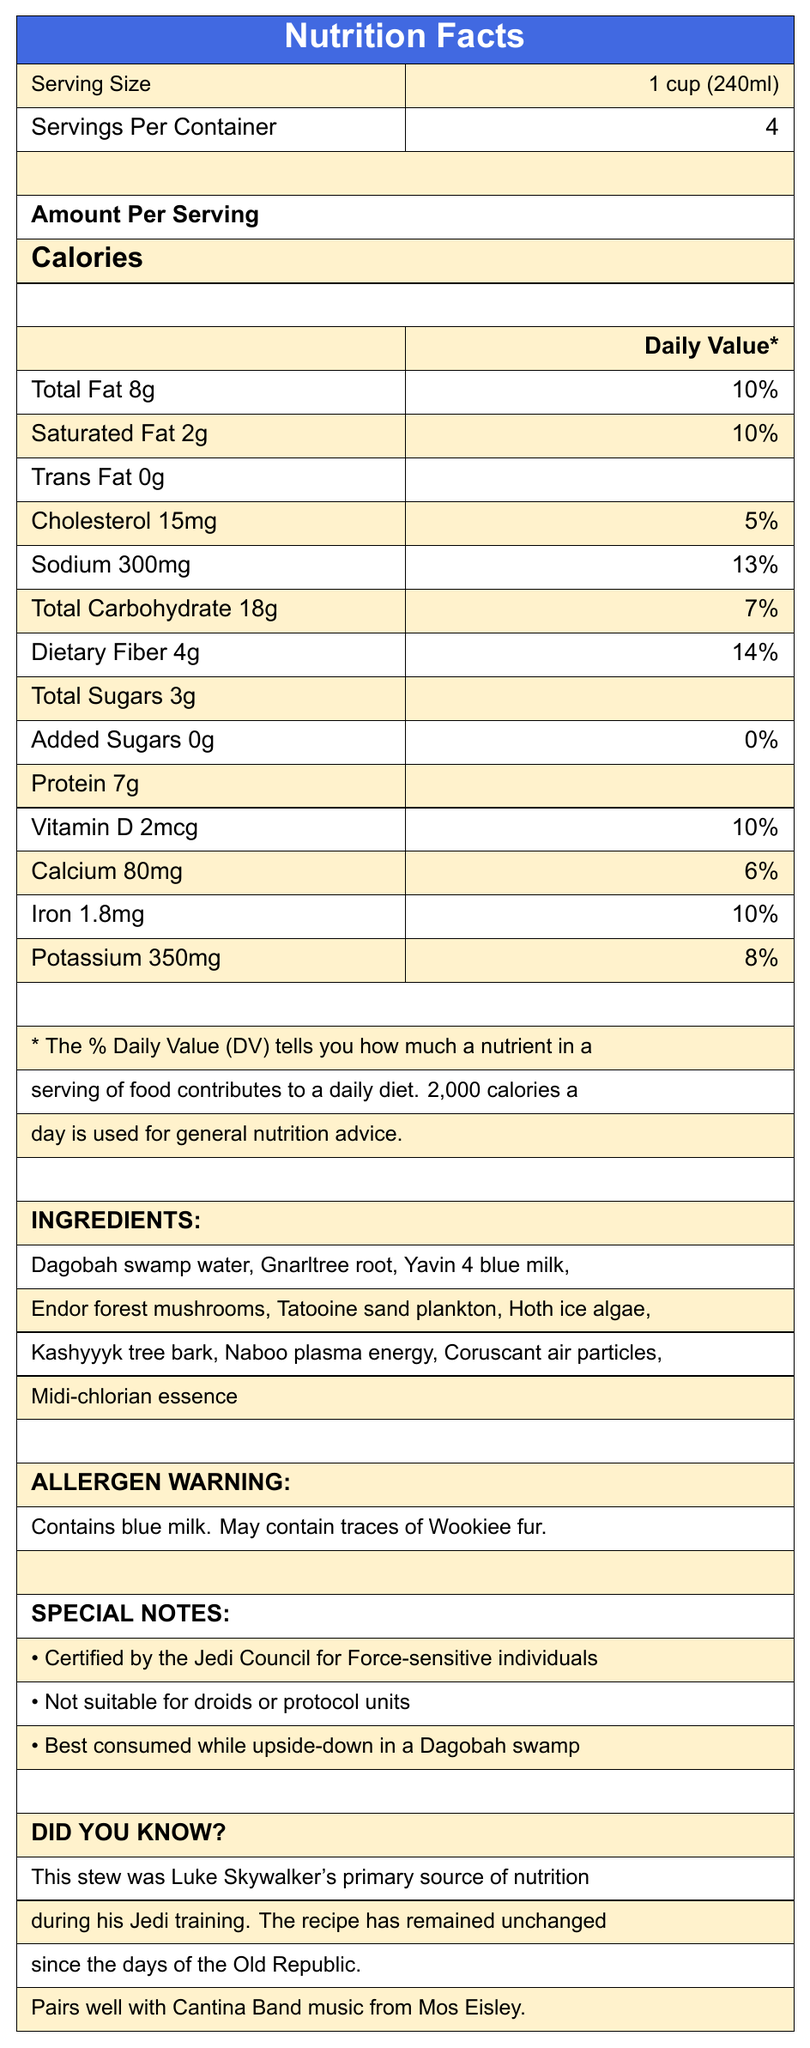what is the serving size? The serving size is explicitly mentioned as 1 cup (240ml) under the "Serving Size" section of the document.
Answer: 1 cup (240ml) how many calories are in one serving? The document states that there are 150 calories per serving under the "Calories" section.
Answer: 150 how much total fat is in each serving and what is its daily value percentage? The document indicates that each serving contains 8g of total fat, which corresponds to 10% of the daily value.
Answer: 8g, 10% what is the primary source of nutrition for Luke Skywalker during his Jedi training? The trivia section mentions that this stew was Luke Skywalker's primary source of nutrition during his Jedi training.
Answer: Yoda's 900-year-old swamp stew how much dietary fiber does each serving contain? According to the nutrition facts, each serving contains 4g of dietary fiber.
Answer: 4g which of these is an ingredient in the stew? A. Tatooine swamp water B. Dagobah swamp water C. Jedi herbs D. Hutt slugs The ingredient list includes Dagobah swamp water.
Answer: B. Dagobah swamp water what allergens are present in Yoda's swamp stew? The allergen warning section indicates that the stew contains blue milk and may contain traces of Wookiee fur.
Answer: Contains blue milk. May contain traces of Wookiee fur. how should the stew be consumed according to the special notes? The special notes section advises that the stew is best consumed while upside-down in a Dagobah swamp.
Answer: Best consumed while upside-down in a Dagobah swamp what is the total carbohydrate content and its daily value percentage in one serving? The document lists the total carbohydrate content as 18g per serving, which is 7% of the daily value.
Answer: 18g, 7% is the stew suitable for droids or protocol units? The special notes mention that the stew is not suitable for droids or protocol units.
Answer: No which special certification does the stew have? A. Droid-compatible B. Certified by the Sith Council C. Certified by the Jedi Council for Force-sensitive individuals The special notes section states that the stew is certified by the Jedi Council for Force-sensitive individuals.
Answer: C. Certified by the Jedi Council for Force-sensitive individuals what is the amount of protein per serving? The nutrition facts list the protein content as 7g per serving.
Answer: 7g list any three ingredients of Yoda's swamp stew. The ingredients listed include Gnarltree root, Yavin 4 blue milk, Endor forest mushrooms, among others.
Answer: Possible answers: Gnarltree root, Yavin 4 blue milk, Endor forest mushrooms what is the main idea of this document? The document extensively covers the nutrition facts, ingredient list, allergen warnings, and special and trivia notes for Yoda's stew. It emphasizes its relevance for Jedi training and the certification by the Jedi Council.
Answer: The document provides a detailed breakdown of the nutritional content, ingredients, allergen information, and special notes for Yoda's 900-year-old swamp stew. It highlights its certification for Force-sensitive individuals and its historical use by Luke Skywalker. how much sodium is in one serving and what is its daily value percentage? The document states that the sodium content per serving is 300mg, which is 13% of the daily value.
Answer: 300mg, 13% does the stew contain added sugars? The nutrition facts indicate that the stew contains 0g of added sugars.
Answer: No, 0g what certification does this stew have? This question is unanswerable as there is no explicit mention of a specific certification like "organic" or "kosher" in the document. However, the document does mention that it is certified by the Jedi Council for Force-sensitive individuals, which doesn't fall under standard certifications like organic or kosher.
Answer: Cannot be determined 